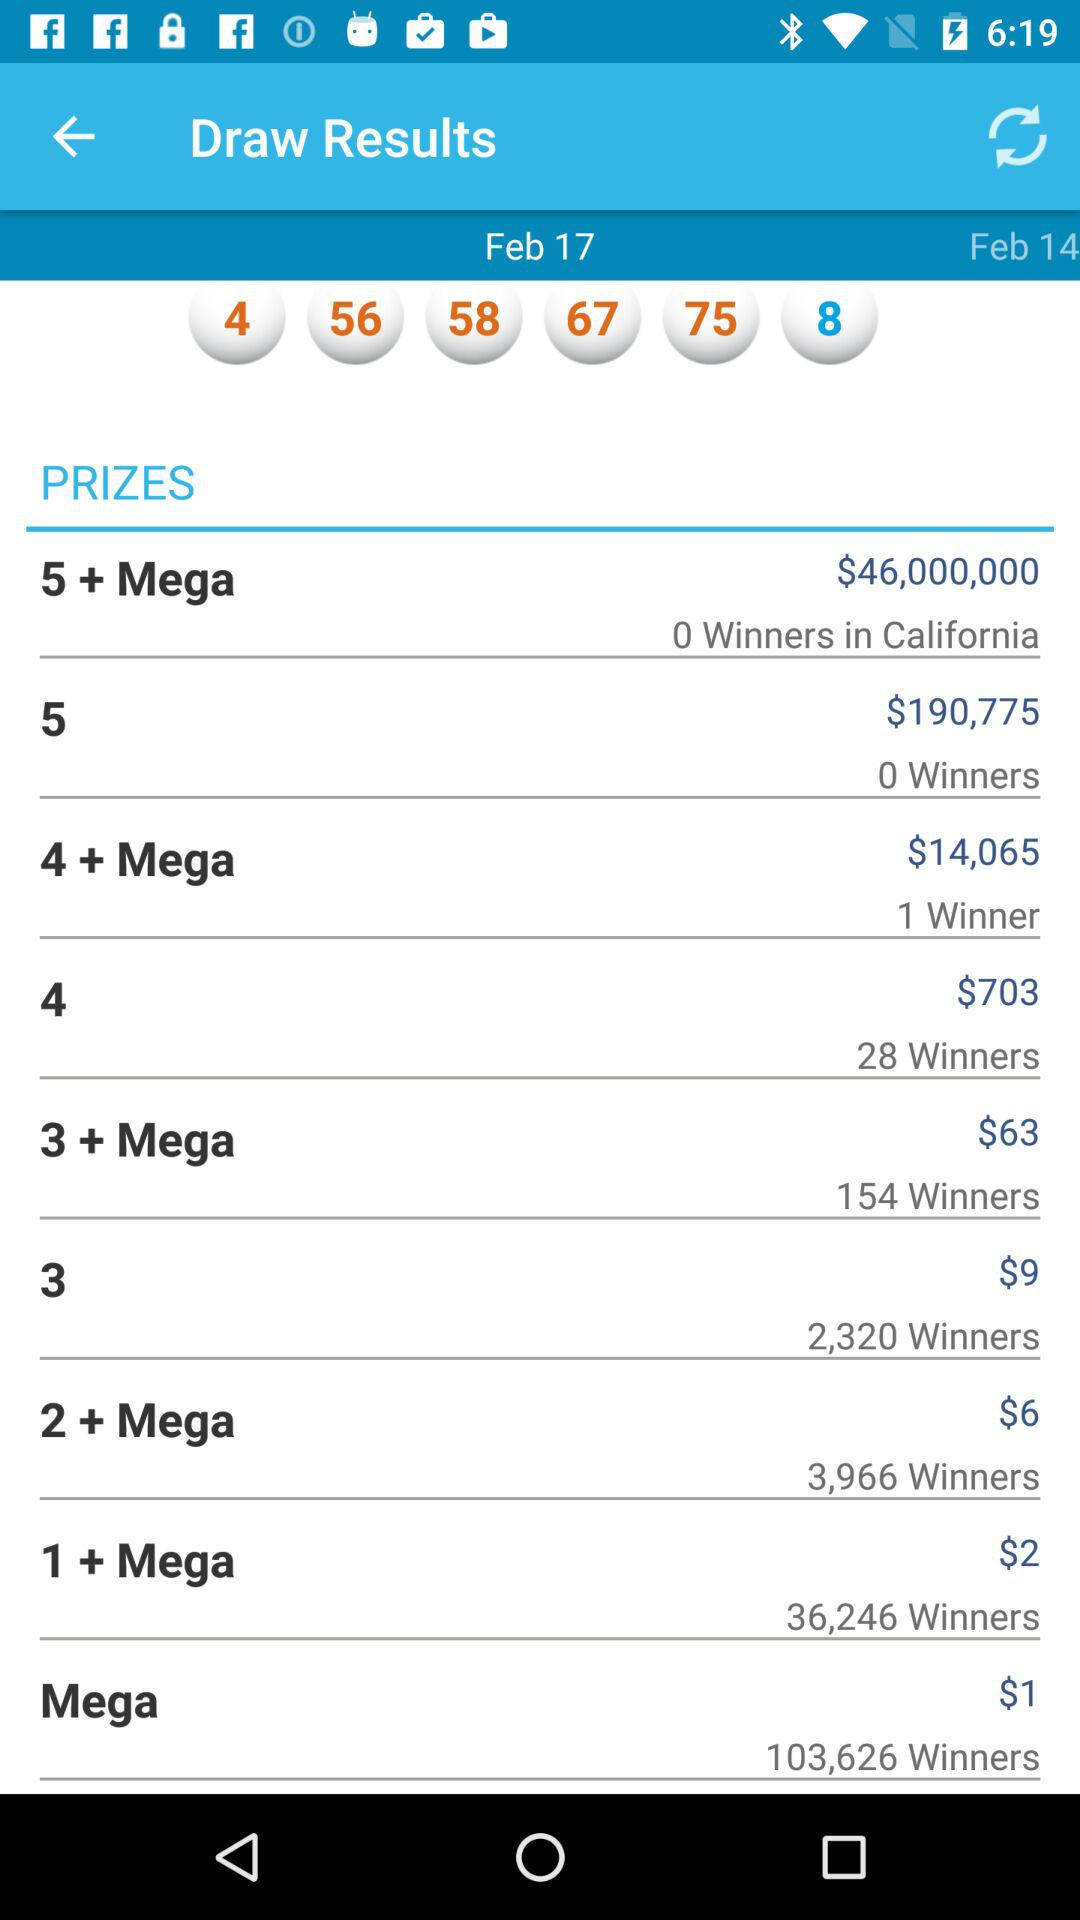What is the date? The dates are February 17 and February 14. 